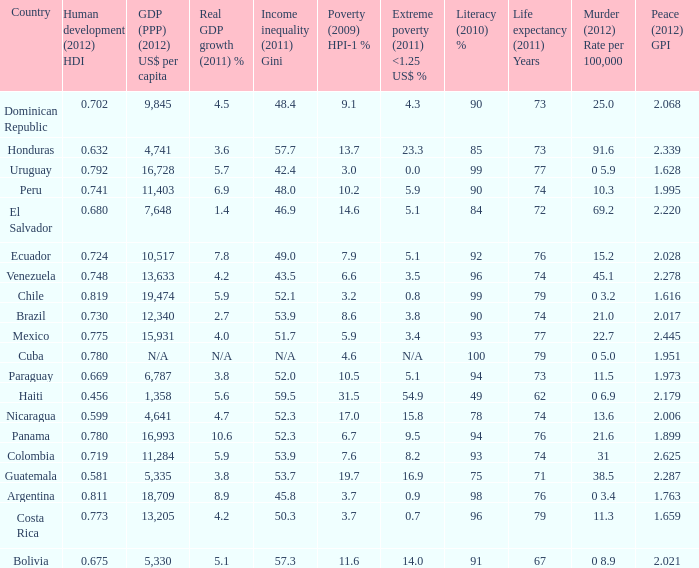What is the total poverty (2009) HPI-1 % when the extreme poverty (2011) <1.25 US$ % of 16.9, and the human development (2012) HDI is less than 0.581? None. 